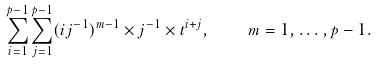Convert formula to latex. <formula><loc_0><loc_0><loc_500><loc_500>\sum _ { i = 1 } ^ { p - 1 } \sum _ { j = 1 } ^ { p - 1 } ( i j ^ { - 1 } ) ^ { m - 1 } \times j ^ { - 1 } \times t ^ { i + j } , \quad m = 1 , \dots , p - 1 .</formula> 